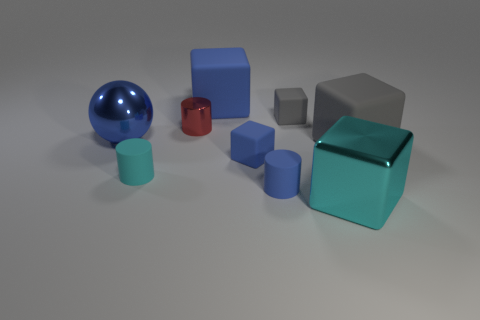What is the lighting like in the scene? The lighting in the image is soft and diffuse, creating gentle shadows and subtle reflections on the objects. It appears to be evenly lit, with no harsh lights or deep shadows, providing a calm and clear view of the objects. 